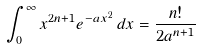<formula> <loc_0><loc_0><loc_500><loc_500>\int _ { 0 } ^ { \infty } x ^ { 2 n + 1 } e ^ { - a x ^ { 2 } } \, d x = { \frac { n ! } { 2 a ^ { n + 1 } } }</formula> 